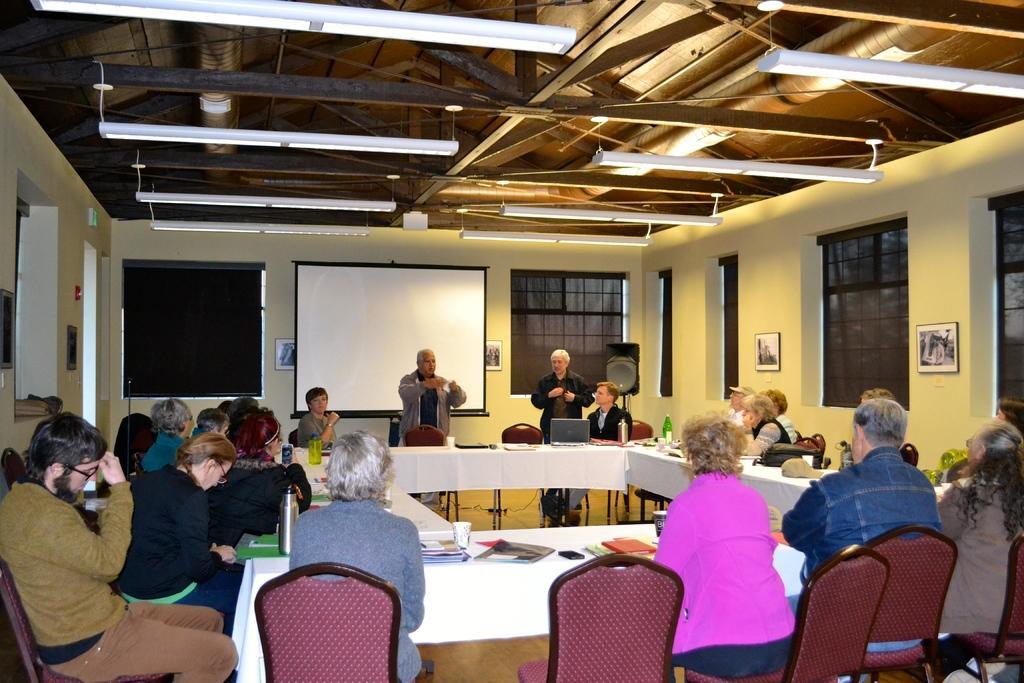How would you summarize this image in a sentence or two? This image is clicked in a meeting room where there are so many tables arranged in a rectangular manner ,there are so many chairs around that tables and so many people are sitting around the table in that chairs. There are books ,Cup ,bottle, laptop, caps on that tables ,there is a man standing in the middle of the image he is explaining something and there are Windows on the right side ,there are tube lights on the top and there is a board in the middle of the image there are window Blinds to the image, to the windows there are photo frames to the wall which are on the left side and right side. 